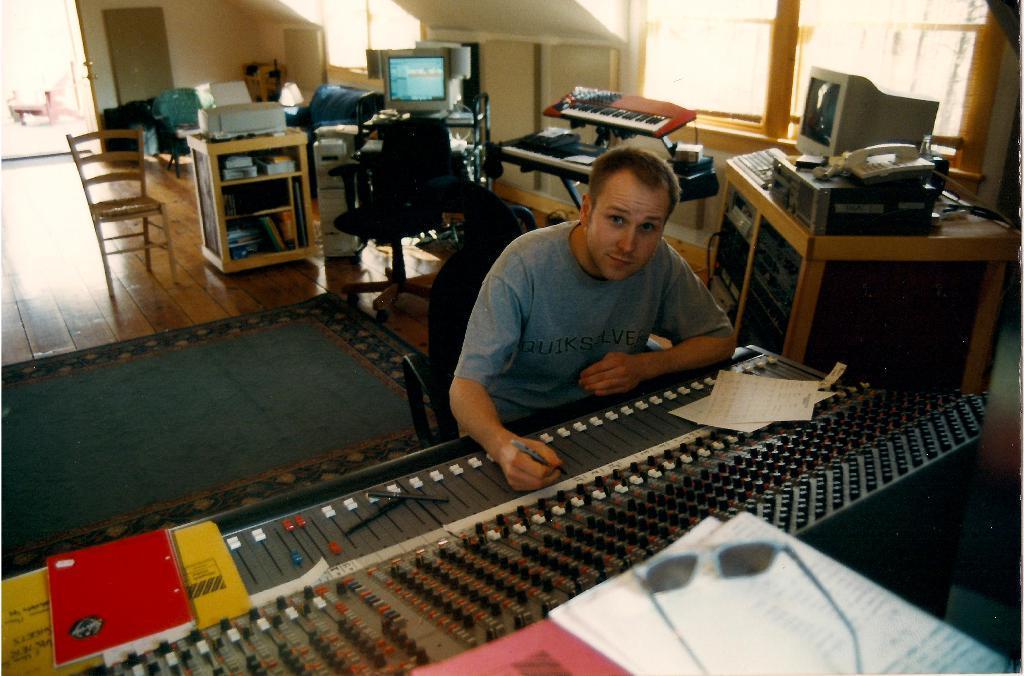Could you give a brief overview of what you see in this image? This picture is clicked inside the room. Man in grey t-shirt sitting on chair is playing musical instrument. Beside him, we see a table on which monitor, land phone and keyboard are placed. Beside that, we see a musical instrument which looks like keyboard and beside that, we see a monitor on the table. On the top of the picture, we see windows and on the left top of the picture, we see a door which is opened. In the middle of the picture, we see table, chair and cupboard. 